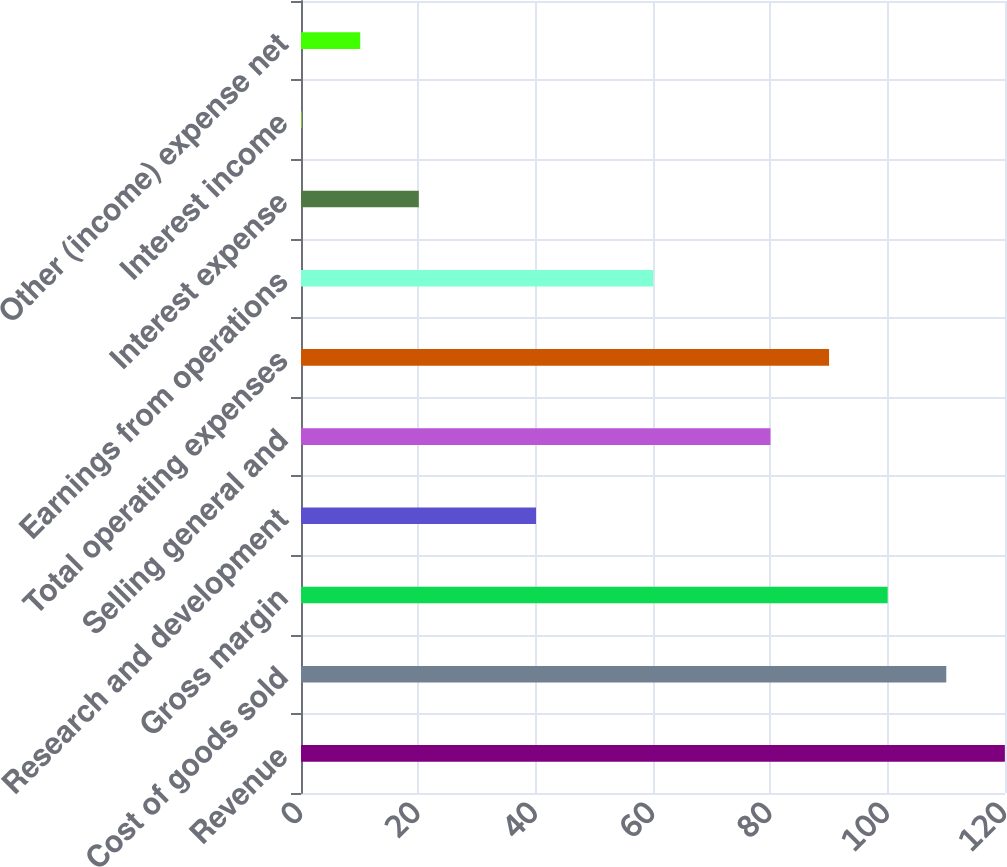Convert chart. <chart><loc_0><loc_0><loc_500><loc_500><bar_chart><fcel>Revenue<fcel>Cost of goods sold<fcel>Gross margin<fcel>Research and development<fcel>Selling general and<fcel>Total operating expenses<fcel>Earnings from operations<fcel>Interest expense<fcel>Interest income<fcel>Other (income) expense net<nl><fcel>119.98<fcel>109.99<fcel>100<fcel>40.06<fcel>80.02<fcel>90.01<fcel>60.04<fcel>20.08<fcel>0.1<fcel>10.09<nl></chart> 